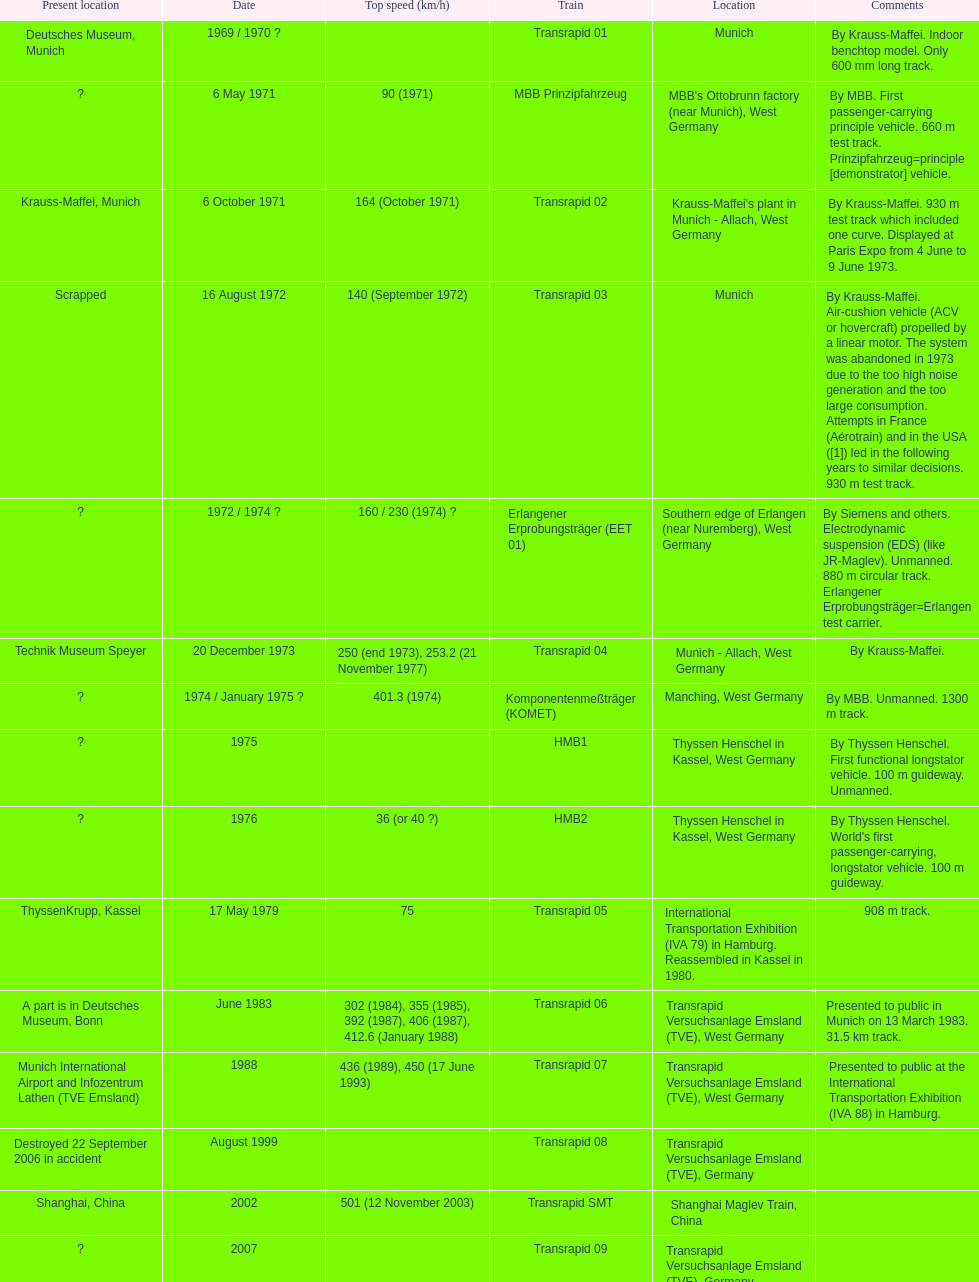How many trains other than the transrapid 07 can go faster than 450km/h? 1. 